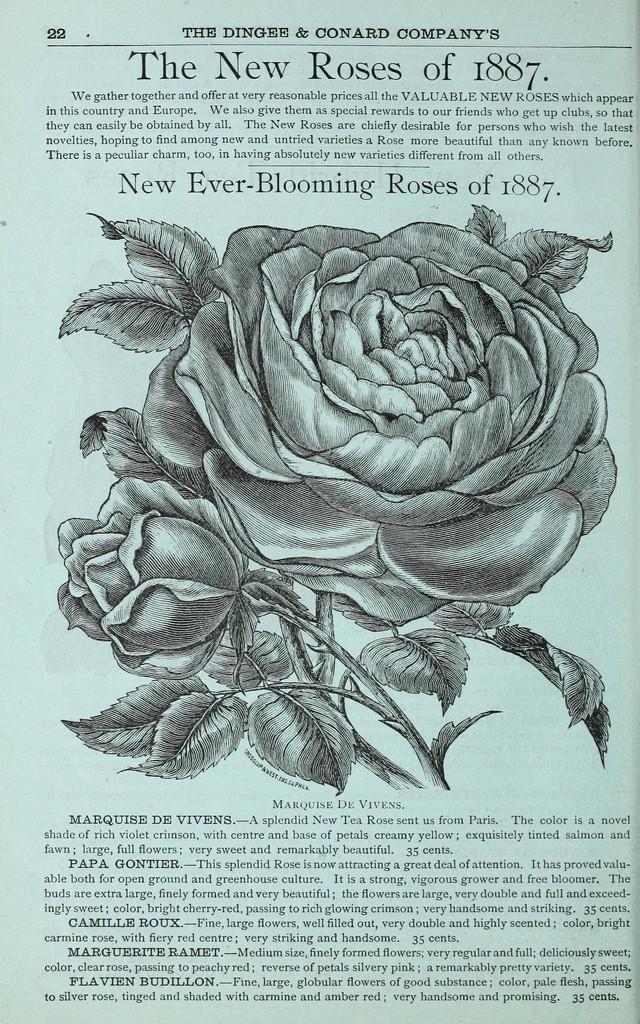In one or two sentences, can you explain what this image depicts? There is a paper on which, there is a drawing of plant which is having rose flowers. On above and below of this drawing, there are texts on the page. 